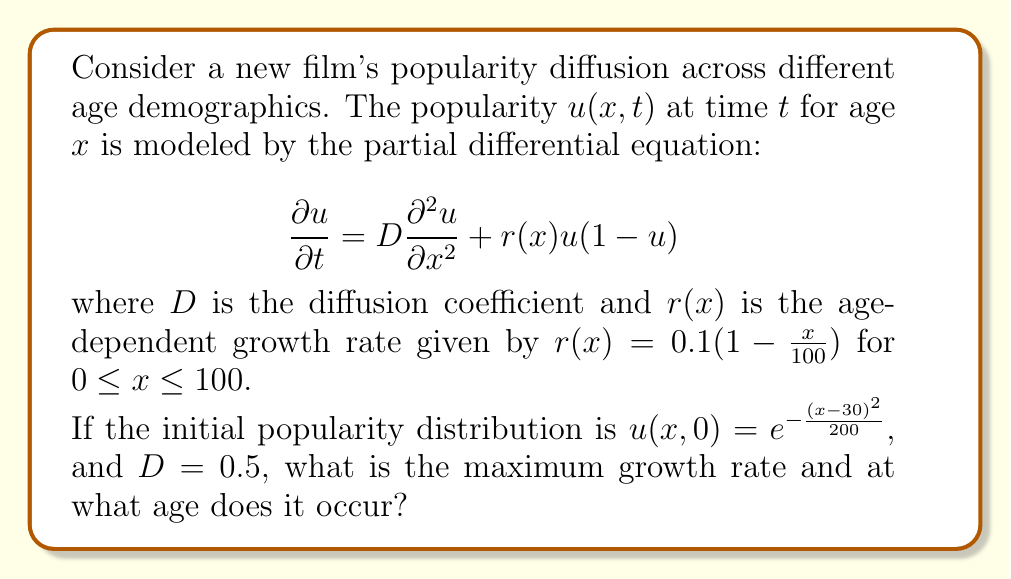Teach me how to tackle this problem. To solve this problem, we need to analyze the growth rate function $r(x)$ and find its maximum value.

1) The growth rate function is given by:
   $r(x) = 0.1(1-\frac{x}{100})$ for $0 \leq x \leq 100$

2) This is a linear function in $x$, decreasing as $x$ increases. The maximum value will occur at the lowest possible value of $x$, which is 0.

3) To find the maximum growth rate:
   $r_{max} = r(0) = 0.1(1-\frac{0}{100}) = 0.1$

4) The age at which this maximum occurs is $x = 0$.

Note: While the initial popularity distribution $u(x,0)$ and the diffusion coefficient $D$ are given, they are not needed to solve this particular question. They would be used if we were solving for the popularity distribution at a later time.
Answer: The maximum growth rate is 0.1, occurring at age 0. 